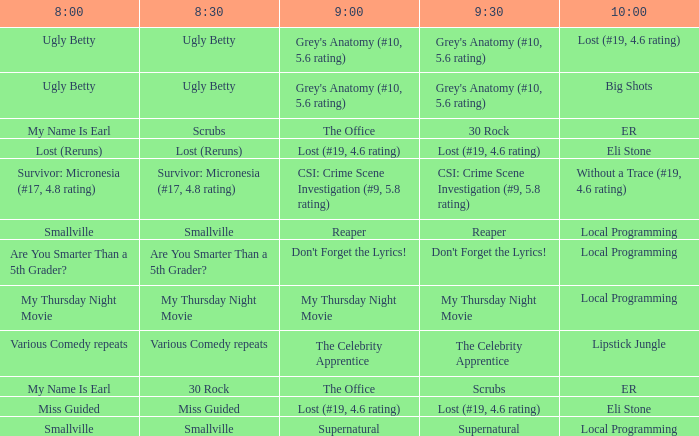What is at 10:00 when at 8:30 it is scrubs? ER. 